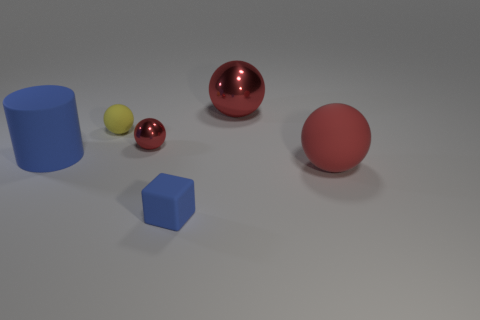Subtract all red balls. How many were subtracted if there are1red balls left? 2 Subtract all yellow cylinders. How many red balls are left? 3 Add 2 tiny cyan metallic balls. How many objects exist? 8 Subtract all cylinders. How many objects are left? 5 Subtract 0 green spheres. How many objects are left? 6 Subtract all big metal objects. Subtract all big metal objects. How many objects are left? 4 Add 4 red shiny things. How many red shiny things are left? 6 Add 2 small blue blocks. How many small blue blocks exist? 3 